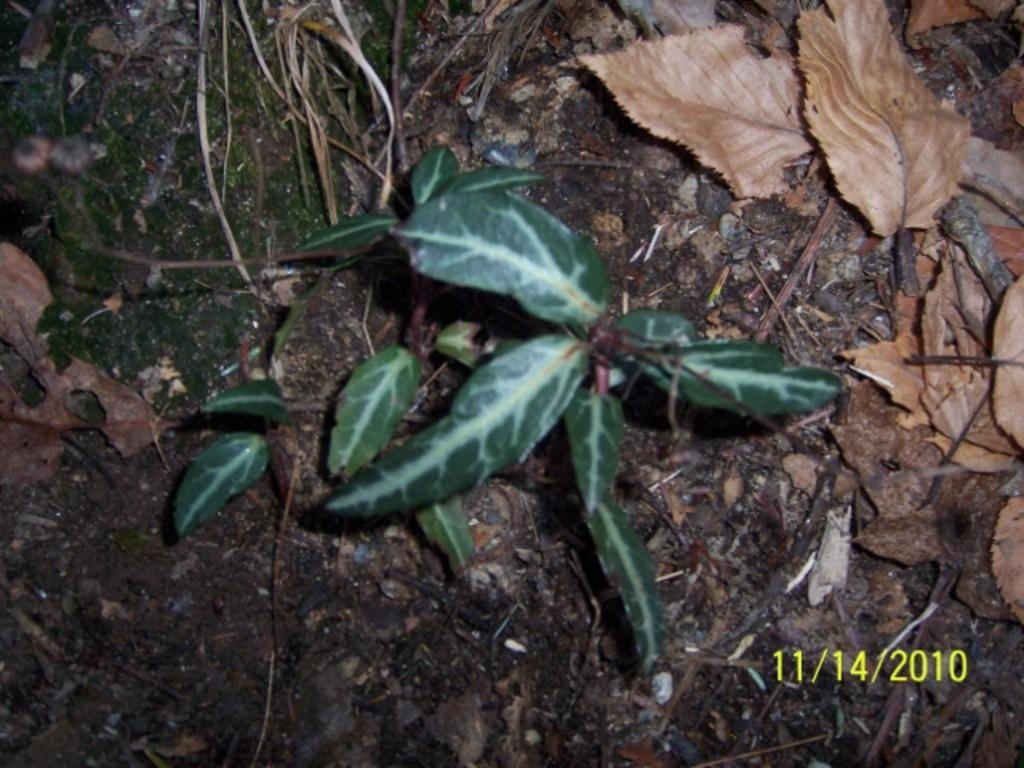What is present in the image? There is a plant in the image. What is the color of the plant? The plant is green in color. Are there any additional features related to the plant in the image? Yes, there are dried leaves beside the plant. How many sisters are walking on the trail in the image? There is no trail or sisters present in the image; it features a plant with dried leaves beside it. What type of orange fruit can be seen in the image? There is no orange fruit present in the image; it features a green plant with dried leaves beside it. 